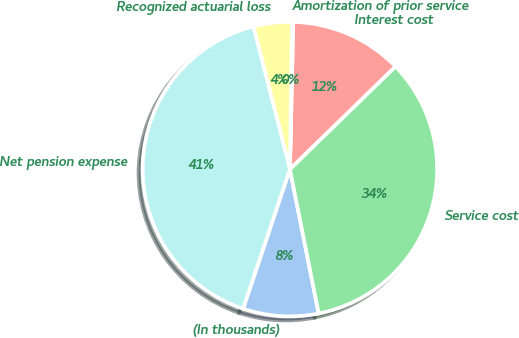Convert chart to OTSL. <chart><loc_0><loc_0><loc_500><loc_500><pie_chart><fcel>(In thousands)<fcel>Service cost<fcel>Interest cost<fcel>Amortization of prior service<fcel>Recognized actuarial loss<fcel>Net pension expense<nl><fcel>8.28%<fcel>34.15%<fcel>12.36%<fcel>0.14%<fcel>4.21%<fcel>40.85%<nl></chart> 